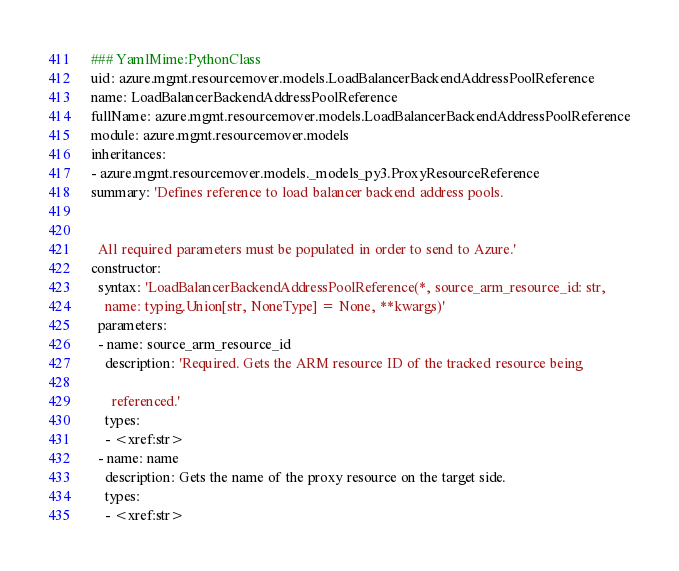<code> <loc_0><loc_0><loc_500><loc_500><_YAML_>### YamlMime:PythonClass
uid: azure.mgmt.resourcemover.models.LoadBalancerBackendAddressPoolReference
name: LoadBalancerBackendAddressPoolReference
fullName: azure.mgmt.resourcemover.models.LoadBalancerBackendAddressPoolReference
module: azure.mgmt.resourcemover.models
inheritances:
- azure.mgmt.resourcemover.models._models_py3.ProxyResourceReference
summary: 'Defines reference to load balancer backend address pools.


  All required parameters must be populated in order to send to Azure.'
constructor:
  syntax: 'LoadBalancerBackendAddressPoolReference(*, source_arm_resource_id: str,
    name: typing.Union[str, NoneType] = None, **kwargs)'
  parameters:
  - name: source_arm_resource_id
    description: 'Required. Gets the ARM resource ID of the tracked resource being

      referenced.'
    types:
    - <xref:str>
  - name: name
    description: Gets the name of the proxy resource on the target side.
    types:
    - <xref:str>
</code> 